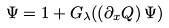Convert formula to latex. <formula><loc_0><loc_0><loc_500><loc_500>\Psi = 1 + G _ { \lambda } ( \left ( { \partial _ { x } Q } \right ) \Psi )</formula> 